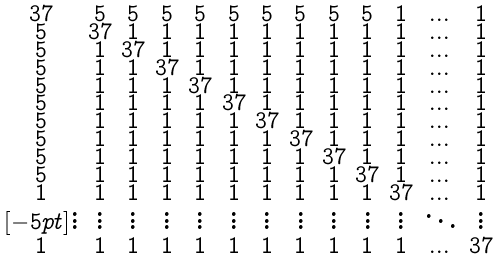<formula> <loc_0><loc_0><loc_500><loc_500>\begin{smallmatrix} 3 7 & 5 & 5 & 5 & 5 & 5 & 5 & 5 & 5 & 5 & 1 & \dots & 1 \\ 5 & 3 7 & 1 & 1 & 1 & 1 & 1 & 1 & 1 & 1 & 1 & \dots & 1 \\ 5 & 1 & 3 7 & 1 & 1 & 1 & 1 & 1 & 1 & 1 & 1 & \dots & 1 \\ 5 & 1 & 1 & 3 7 & 1 & 1 & 1 & 1 & 1 & 1 & 1 & \dots & 1 \\ 5 & 1 & 1 & 1 & 3 7 & 1 & 1 & 1 & 1 & 1 & 1 & \dots & 1 \\ 5 & 1 & 1 & 1 & 1 & 3 7 & 1 & 1 & 1 & 1 & 1 & \dots & 1 \\ 5 & 1 & 1 & 1 & 1 & 1 & 3 7 & 1 & 1 & 1 & 1 & \dots & 1 \\ 5 & 1 & 1 & 1 & 1 & 1 & 1 & 3 7 & 1 & 1 & 1 & \dots & 1 \\ 5 & 1 & 1 & 1 & 1 & 1 & 1 & 1 & 3 7 & 1 & 1 & \dots & 1 \\ 5 & 1 & 1 & 1 & 1 & 1 & 1 & 1 & 1 & 3 7 & 1 & \dots & 1 \\ 1 & 1 & 1 & 1 & 1 & 1 & 1 & 1 & 1 & 1 & 3 7 & \dots & 1 \\ [ - 5 p t ] \vdots & \vdots & \vdots & \vdots & \vdots & \vdots & \vdots & \vdots & \vdots & \vdots & \vdots & \ddots & \vdots \\ 1 & 1 & 1 & 1 & 1 & 1 & 1 & 1 & 1 & 1 & 1 & \dots & 3 7 \\ \end{smallmatrix}</formula> 